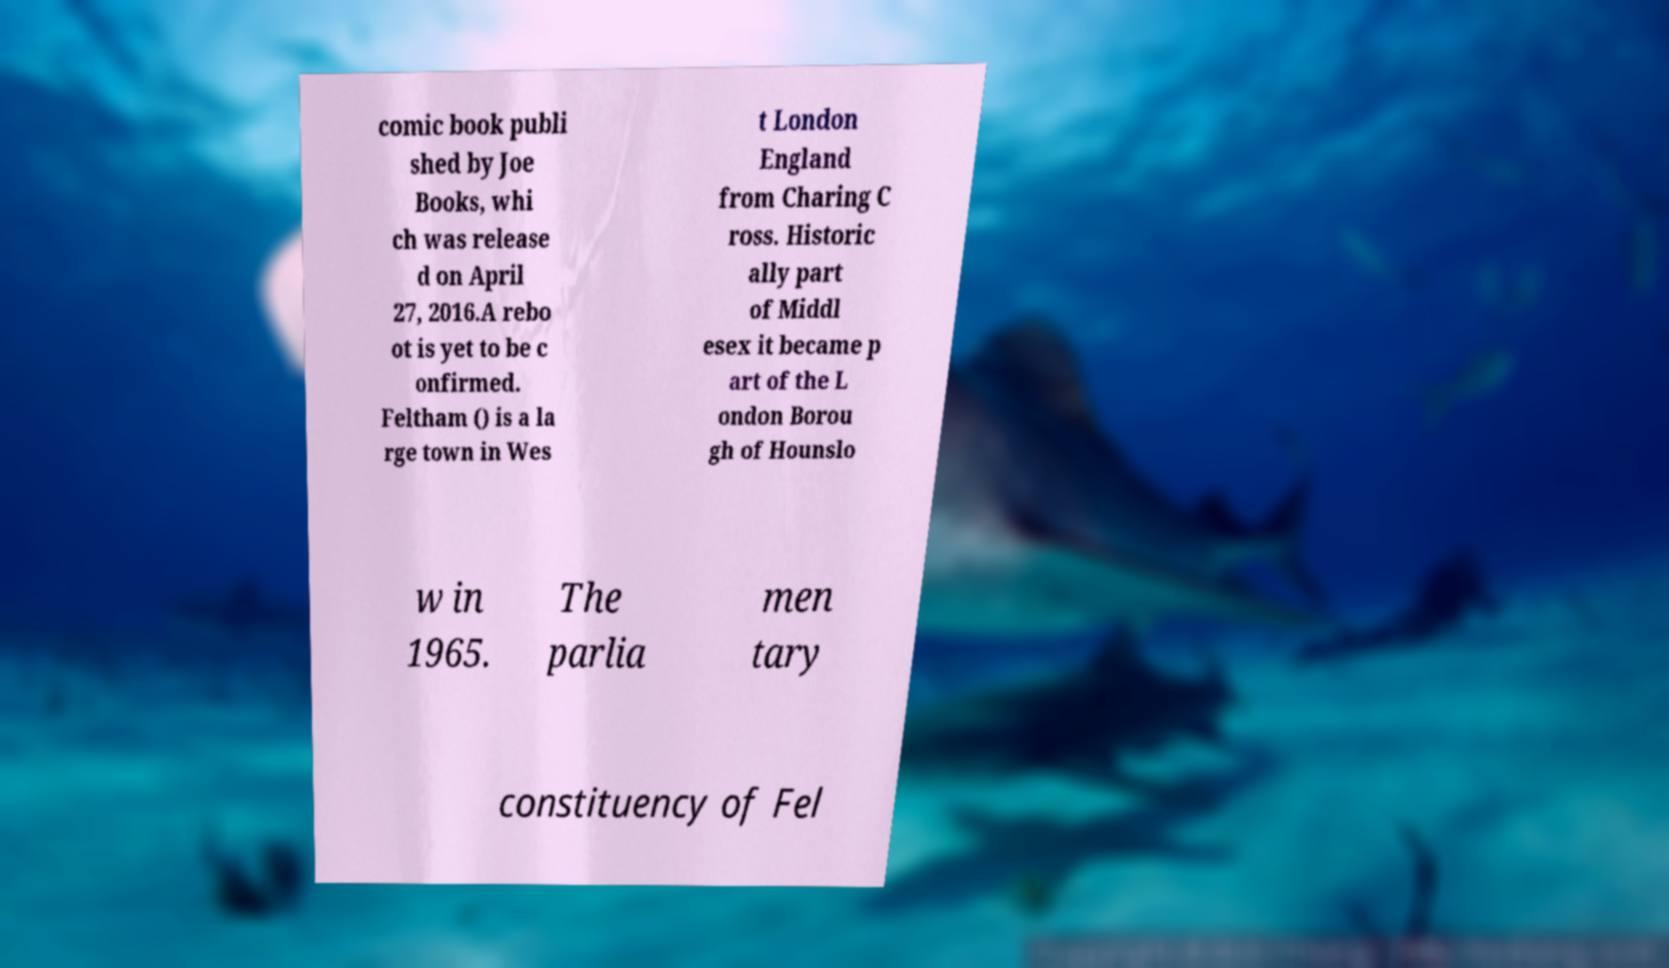Please identify and transcribe the text found in this image. comic book publi shed by Joe Books, whi ch was release d on April 27, 2016.A rebo ot is yet to be c onfirmed. Feltham () is a la rge town in Wes t London England from Charing C ross. Historic ally part of Middl esex it became p art of the L ondon Borou gh of Hounslo w in 1965. The parlia men tary constituency of Fel 